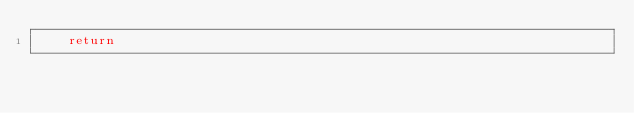Convert code to text. <code><loc_0><loc_0><loc_500><loc_500><_Python_>    return</code> 